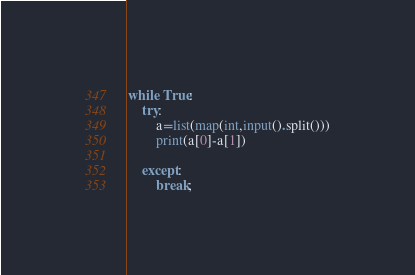<code> <loc_0><loc_0><loc_500><loc_500><_Python_>while True:
    try:
        a=list(map(int,input().split()))
        print(a[0]-a[1])
        
    except:
        break;
</code> 